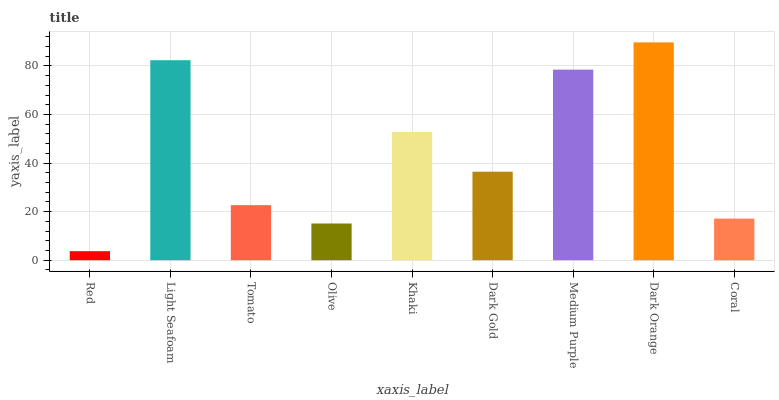Is Red the minimum?
Answer yes or no. Yes. Is Dark Orange the maximum?
Answer yes or no. Yes. Is Light Seafoam the minimum?
Answer yes or no. No. Is Light Seafoam the maximum?
Answer yes or no. No. Is Light Seafoam greater than Red?
Answer yes or no. Yes. Is Red less than Light Seafoam?
Answer yes or no. Yes. Is Red greater than Light Seafoam?
Answer yes or no. No. Is Light Seafoam less than Red?
Answer yes or no. No. Is Dark Gold the high median?
Answer yes or no. Yes. Is Dark Gold the low median?
Answer yes or no. Yes. Is Medium Purple the high median?
Answer yes or no. No. Is Red the low median?
Answer yes or no. No. 